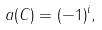Convert formula to latex. <formula><loc_0><loc_0><loc_500><loc_500>a ( C ) = ( - 1 ) ^ { i } ,</formula> 